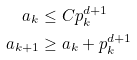<formula> <loc_0><loc_0><loc_500><loc_500>a _ { k } & \leq C p _ { k } ^ { d + 1 } \\ a _ { k + 1 } & \geq a _ { k } + p _ { k } ^ { d + 1 }</formula> 